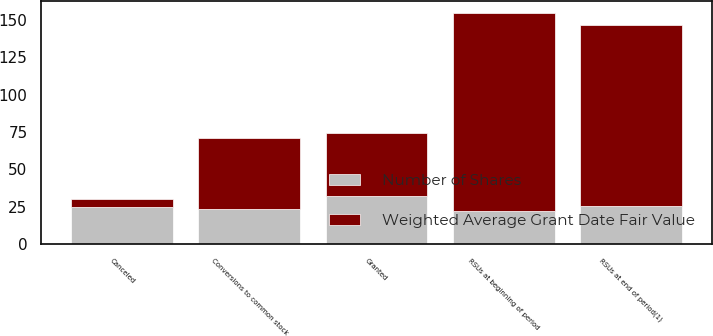<chart> <loc_0><loc_0><loc_500><loc_500><stacked_bar_chart><ecel><fcel>RSUs at beginning of period<fcel>Granted<fcel>Conversions to common stock<fcel>Canceled<fcel>RSUs at end of period(1)<nl><fcel>Weighted Average Grant Date Fair Value<fcel>132<fcel>42<fcel>48<fcel>5<fcel>121<nl><fcel>Number of Shares<fcel>22.41<fcel>32.58<fcel>23.26<fcel>25.04<fcel>25.52<nl></chart> 